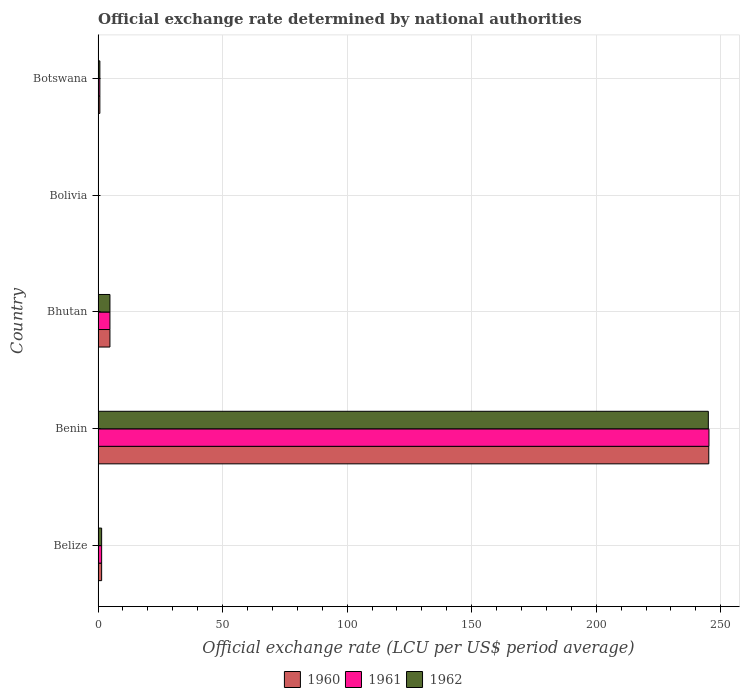Are the number of bars on each tick of the Y-axis equal?
Your answer should be very brief. Yes. What is the label of the 2nd group of bars from the top?
Keep it short and to the point. Bolivia. What is the official exchange rate in 1962 in Benin?
Offer a very short reply. 245.01. Across all countries, what is the maximum official exchange rate in 1962?
Your answer should be compact. 245.01. Across all countries, what is the minimum official exchange rate in 1961?
Offer a terse response. 1.188e-5. In which country was the official exchange rate in 1962 maximum?
Give a very brief answer. Benin. In which country was the official exchange rate in 1960 minimum?
Offer a terse response. Bolivia. What is the total official exchange rate in 1962 in the graph?
Make the answer very short. 251.92. What is the difference between the official exchange rate in 1960 in Bolivia and that in Botswana?
Your answer should be very brief. -0.71. What is the difference between the official exchange rate in 1962 in Bolivia and the official exchange rate in 1961 in Bhutan?
Your answer should be compact. -4.76. What is the average official exchange rate in 1962 per country?
Offer a very short reply. 50.38. In how many countries, is the official exchange rate in 1960 greater than 110 LCU?
Your answer should be very brief. 1. What is the ratio of the official exchange rate in 1961 in Belize to that in Bolivia?
Your response must be concise. 1.20e+05. Is the official exchange rate in 1960 in Benin less than that in Botswana?
Offer a very short reply. No. Is the difference between the official exchange rate in 1961 in Benin and Bhutan greater than the difference between the official exchange rate in 1962 in Benin and Bhutan?
Your answer should be compact. Yes. What is the difference between the highest and the second highest official exchange rate in 1961?
Ensure brevity in your answer.  240.5. What is the difference between the highest and the lowest official exchange rate in 1960?
Keep it short and to the point. 245.2. In how many countries, is the official exchange rate in 1962 greater than the average official exchange rate in 1962 taken over all countries?
Provide a succinct answer. 1. Is the sum of the official exchange rate in 1962 in Benin and Botswana greater than the maximum official exchange rate in 1960 across all countries?
Offer a terse response. Yes. What does the 3rd bar from the top in Belize represents?
Give a very brief answer. 1960. What does the 1st bar from the bottom in Bolivia represents?
Provide a succinct answer. 1960. Is it the case that in every country, the sum of the official exchange rate in 1960 and official exchange rate in 1962 is greater than the official exchange rate in 1961?
Make the answer very short. Yes. How many bars are there?
Provide a short and direct response. 15. How many countries are there in the graph?
Give a very brief answer. 5. What is the difference between two consecutive major ticks on the X-axis?
Provide a succinct answer. 50. Are the values on the major ticks of X-axis written in scientific E-notation?
Give a very brief answer. No. Does the graph contain any zero values?
Your answer should be very brief. No. Does the graph contain grids?
Give a very brief answer. Yes. What is the title of the graph?
Your answer should be compact. Official exchange rate determined by national authorities. Does "1974" appear as one of the legend labels in the graph?
Provide a short and direct response. No. What is the label or title of the X-axis?
Keep it short and to the point. Official exchange rate (LCU per US$ period average). What is the label or title of the Y-axis?
Your answer should be compact. Country. What is the Official exchange rate (LCU per US$ period average) of 1960 in Belize?
Your answer should be compact. 1.43. What is the Official exchange rate (LCU per US$ period average) in 1961 in Belize?
Your response must be concise. 1.43. What is the Official exchange rate (LCU per US$ period average) of 1962 in Belize?
Make the answer very short. 1.43. What is the Official exchange rate (LCU per US$ period average) of 1960 in Benin?
Ensure brevity in your answer.  245.2. What is the Official exchange rate (LCU per US$ period average) in 1961 in Benin?
Keep it short and to the point. 245.26. What is the Official exchange rate (LCU per US$ period average) in 1962 in Benin?
Keep it short and to the point. 245.01. What is the Official exchange rate (LCU per US$ period average) of 1960 in Bhutan?
Offer a very short reply. 4.76. What is the Official exchange rate (LCU per US$ period average) of 1961 in Bhutan?
Give a very brief answer. 4.76. What is the Official exchange rate (LCU per US$ period average) of 1962 in Bhutan?
Your answer should be compact. 4.76. What is the Official exchange rate (LCU per US$ period average) in 1960 in Bolivia?
Your answer should be compact. 1.188e-5. What is the Official exchange rate (LCU per US$ period average) in 1961 in Bolivia?
Offer a very short reply. 1.188e-5. What is the Official exchange rate (LCU per US$ period average) of 1962 in Bolivia?
Offer a terse response. 1.188e-5. What is the Official exchange rate (LCU per US$ period average) in 1960 in Botswana?
Ensure brevity in your answer.  0.71. What is the Official exchange rate (LCU per US$ period average) in 1961 in Botswana?
Your answer should be very brief. 0.71. What is the Official exchange rate (LCU per US$ period average) of 1962 in Botswana?
Provide a short and direct response. 0.71. Across all countries, what is the maximum Official exchange rate (LCU per US$ period average) in 1960?
Offer a very short reply. 245.2. Across all countries, what is the maximum Official exchange rate (LCU per US$ period average) in 1961?
Ensure brevity in your answer.  245.26. Across all countries, what is the maximum Official exchange rate (LCU per US$ period average) of 1962?
Give a very brief answer. 245.01. Across all countries, what is the minimum Official exchange rate (LCU per US$ period average) in 1960?
Your answer should be very brief. 1.188e-5. Across all countries, what is the minimum Official exchange rate (LCU per US$ period average) in 1961?
Give a very brief answer. 1.188e-5. Across all countries, what is the minimum Official exchange rate (LCU per US$ period average) of 1962?
Your answer should be very brief. 1.188e-5. What is the total Official exchange rate (LCU per US$ period average) in 1960 in the graph?
Offer a very short reply. 252.1. What is the total Official exchange rate (LCU per US$ period average) of 1961 in the graph?
Offer a very short reply. 252.17. What is the total Official exchange rate (LCU per US$ period average) in 1962 in the graph?
Give a very brief answer. 251.92. What is the difference between the Official exchange rate (LCU per US$ period average) in 1960 in Belize and that in Benin?
Keep it short and to the point. -243.77. What is the difference between the Official exchange rate (LCU per US$ period average) of 1961 in Belize and that in Benin?
Give a very brief answer. -243.83. What is the difference between the Official exchange rate (LCU per US$ period average) in 1962 in Belize and that in Benin?
Keep it short and to the point. -243.59. What is the difference between the Official exchange rate (LCU per US$ period average) of 1962 in Belize and that in Bhutan?
Make the answer very short. -3.33. What is the difference between the Official exchange rate (LCU per US$ period average) of 1960 in Belize and that in Bolivia?
Offer a very short reply. 1.43. What is the difference between the Official exchange rate (LCU per US$ period average) of 1961 in Belize and that in Bolivia?
Offer a terse response. 1.43. What is the difference between the Official exchange rate (LCU per US$ period average) of 1962 in Belize and that in Bolivia?
Your response must be concise. 1.43. What is the difference between the Official exchange rate (LCU per US$ period average) in 1960 in Belize and that in Botswana?
Your response must be concise. 0.72. What is the difference between the Official exchange rate (LCU per US$ period average) of 1961 in Belize and that in Botswana?
Your answer should be very brief. 0.71. What is the difference between the Official exchange rate (LCU per US$ period average) of 1962 in Belize and that in Botswana?
Offer a very short reply. 0.72. What is the difference between the Official exchange rate (LCU per US$ period average) in 1960 in Benin and that in Bhutan?
Offer a terse response. 240.43. What is the difference between the Official exchange rate (LCU per US$ period average) in 1961 in Benin and that in Bhutan?
Provide a short and direct response. 240.5. What is the difference between the Official exchange rate (LCU per US$ period average) of 1962 in Benin and that in Bhutan?
Make the answer very short. 240.25. What is the difference between the Official exchange rate (LCU per US$ period average) in 1960 in Benin and that in Bolivia?
Offer a very short reply. 245.2. What is the difference between the Official exchange rate (LCU per US$ period average) of 1961 in Benin and that in Bolivia?
Provide a short and direct response. 245.26. What is the difference between the Official exchange rate (LCU per US$ period average) of 1962 in Benin and that in Bolivia?
Give a very brief answer. 245.01. What is the difference between the Official exchange rate (LCU per US$ period average) in 1960 in Benin and that in Botswana?
Ensure brevity in your answer.  244.48. What is the difference between the Official exchange rate (LCU per US$ period average) in 1961 in Benin and that in Botswana?
Offer a very short reply. 244.55. What is the difference between the Official exchange rate (LCU per US$ period average) in 1962 in Benin and that in Botswana?
Your answer should be compact. 244.3. What is the difference between the Official exchange rate (LCU per US$ period average) in 1960 in Bhutan and that in Bolivia?
Provide a short and direct response. 4.76. What is the difference between the Official exchange rate (LCU per US$ period average) of 1961 in Bhutan and that in Bolivia?
Ensure brevity in your answer.  4.76. What is the difference between the Official exchange rate (LCU per US$ period average) in 1962 in Bhutan and that in Bolivia?
Keep it short and to the point. 4.76. What is the difference between the Official exchange rate (LCU per US$ period average) in 1960 in Bhutan and that in Botswana?
Provide a short and direct response. 4.05. What is the difference between the Official exchange rate (LCU per US$ period average) of 1961 in Bhutan and that in Botswana?
Keep it short and to the point. 4.05. What is the difference between the Official exchange rate (LCU per US$ period average) of 1962 in Bhutan and that in Botswana?
Provide a short and direct response. 4.05. What is the difference between the Official exchange rate (LCU per US$ period average) in 1960 in Bolivia and that in Botswana?
Offer a terse response. -0.71. What is the difference between the Official exchange rate (LCU per US$ period average) of 1961 in Bolivia and that in Botswana?
Make the answer very short. -0.71. What is the difference between the Official exchange rate (LCU per US$ period average) in 1962 in Bolivia and that in Botswana?
Offer a very short reply. -0.71. What is the difference between the Official exchange rate (LCU per US$ period average) of 1960 in Belize and the Official exchange rate (LCU per US$ period average) of 1961 in Benin?
Offer a terse response. -243.83. What is the difference between the Official exchange rate (LCU per US$ period average) in 1960 in Belize and the Official exchange rate (LCU per US$ period average) in 1962 in Benin?
Your answer should be compact. -243.59. What is the difference between the Official exchange rate (LCU per US$ period average) in 1961 in Belize and the Official exchange rate (LCU per US$ period average) in 1962 in Benin?
Offer a terse response. -243.59. What is the difference between the Official exchange rate (LCU per US$ period average) of 1961 in Belize and the Official exchange rate (LCU per US$ period average) of 1962 in Bhutan?
Give a very brief answer. -3.33. What is the difference between the Official exchange rate (LCU per US$ period average) of 1960 in Belize and the Official exchange rate (LCU per US$ period average) of 1961 in Bolivia?
Give a very brief answer. 1.43. What is the difference between the Official exchange rate (LCU per US$ period average) of 1960 in Belize and the Official exchange rate (LCU per US$ period average) of 1962 in Bolivia?
Offer a terse response. 1.43. What is the difference between the Official exchange rate (LCU per US$ period average) in 1961 in Belize and the Official exchange rate (LCU per US$ period average) in 1962 in Bolivia?
Provide a succinct answer. 1.43. What is the difference between the Official exchange rate (LCU per US$ period average) of 1960 in Belize and the Official exchange rate (LCU per US$ period average) of 1961 in Botswana?
Your response must be concise. 0.71. What is the difference between the Official exchange rate (LCU per US$ period average) of 1960 in Belize and the Official exchange rate (LCU per US$ period average) of 1962 in Botswana?
Provide a short and direct response. 0.72. What is the difference between the Official exchange rate (LCU per US$ period average) of 1961 in Belize and the Official exchange rate (LCU per US$ period average) of 1962 in Botswana?
Offer a terse response. 0.72. What is the difference between the Official exchange rate (LCU per US$ period average) of 1960 in Benin and the Official exchange rate (LCU per US$ period average) of 1961 in Bhutan?
Keep it short and to the point. 240.43. What is the difference between the Official exchange rate (LCU per US$ period average) in 1960 in Benin and the Official exchange rate (LCU per US$ period average) in 1962 in Bhutan?
Provide a succinct answer. 240.43. What is the difference between the Official exchange rate (LCU per US$ period average) in 1961 in Benin and the Official exchange rate (LCU per US$ period average) in 1962 in Bhutan?
Your answer should be very brief. 240.5. What is the difference between the Official exchange rate (LCU per US$ period average) in 1960 in Benin and the Official exchange rate (LCU per US$ period average) in 1961 in Bolivia?
Provide a succinct answer. 245.2. What is the difference between the Official exchange rate (LCU per US$ period average) in 1960 in Benin and the Official exchange rate (LCU per US$ period average) in 1962 in Bolivia?
Provide a succinct answer. 245.2. What is the difference between the Official exchange rate (LCU per US$ period average) in 1961 in Benin and the Official exchange rate (LCU per US$ period average) in 1962 in Bolivia?
Keep it short and to the point. 245.26. What is the difference between the Official exchange rate (LCU per US$ period average) of 1960 in Benin and the Official exchange rate (LCU per US$ period average) of 1961 in Botswana?
Keep it short and to the point. 244.48. What is the difference between the Official exchange rate (LCU per US$ period average) in 1960 in Benin and the Official exchange rate (LCU per US$ period average) in 1962 in Botswana?
Provide a short and direct response. 244.48. What is the difference between the Official exchange rate (LCU per US$ period average) in 1961 in Benin and the Official exchange rate (LCU per US$ period average) in 1962 in Botswana?
Your answer should be compact. 244.55. What is the difference between the Official exchange rate (LCU per US$ period average) in 1960 in Bhutan and the Official exchange rate (LCU per US$ period average) in 1961 in Bolivia?
Provide a succinct answer. 4.76. What is the difference between the Official exchange rate (LCU per US$ period average) of 1960 in Bhutan and the Official exchange rate (LCU per US$ period average) of 1962 in Bolivia?
Ensure brevity in your answer.  4.76. What is the difference between the Official exchange rate (LCU per US$ period average) in 1961 in Bhutan and the Official exchange rate (LCU per US$ period average) in 1962 in Bolivia?
Give a very brief answer. 4.76. What is the difference between the Official exchange rate (LCU per US$ period average) in 1960 in Bhutan and the Official exchange rate (LCU per US$ period average) in 1961 in Botswana?
Make the answer very short. 4.05. What is the difference between the Official exchange rate (LCU per US$ period average) of 1960 in Bhutan and the Official exchange rate (LCU per US$ period average) of 1962 in Botswana?
Provide a succinct answer. 4.05. What is the difference between the Official exchange rate (LCU per US$ period average) of 1961 in Bhutan and the Official exchange rate (LCU per US$ period average) of 1962 in Botswana?
Your answer should be compact. 4.05. What is the difference between the Official exchange rate (LCU per US$ period average) of 1960 in Bolivia and the Official exchange rate (LCU per US$ period average) of 1961 in Botswana?
Make the answer very short. -0.71. What is the difference between the Official exchange rate (LCU per US$ period average) in 1960 in Bolivia and the Official exchange rate (LCU per US$ period average) in 1962 in Botswana?
Make the answer very short. -0.71. What is the difference between the Official exchange rate (LCU per US$ period average) in 1961 in Bolivia and the Official exchange rate (LCU per US$ period average) in 1962 in Botswana?
Ensure brevity in your answer.  -0.71. What is the average Official exchange rate (LCU per US$ period average) in 1960 per country?
Your answer should be compact. 50.42. What is the average Official exchange rate (LCU per US$ period average) in 1961 per country?
Keep it short and to the point. 50.43. What is the average Official exchange rate (LCU per US$ period average) in 1962 per country?
Keep it short and to the point. 50.38. What is the difference between the Official exchange rate (LCU per US$ period average) of 1960 and Official exchange rate (LCU per US$ period average) of 1961 in Belize?
Give a very brief answer. 0. What is the difference between the Official exchange rate (LCU per US$ period average) of 1961 and Official exchange rate (LCU per US$ period average) of 1962 in Belize?
Ensure brevity in your answer.  0. What is the difference between the Official exchange rate (LCU per US$ period average) in 1960 and Official exchange rate (LCU per US$ period average) in 1961 in Benin?
Ensure brevity in your answer.  -0.07. What is the difference between the Official exchange rate (LCU per US$ period average) of 1960 and Official exchange rate (LCU per US$ period average) of 1962 in Benin?
Your response must be concise. 0.18. What is the difference between the Official exchange rate (LCU per US$ period average) in 1961 and Official exchange rate (LCU per US$ period average) in 1962 in Benin?
Keep it short and to the point. 0.25. What is the difference between the Official exchange rate (LCU per US$ period average) in 1960 and Official exchange rate (LCU per US$ period average) in 1962 in Bhutan?
Offer a terse response. 0. What is the difference between the Official exchange rate (LCU per US$ period average) in 1961 and Official exchange rate (LCU per US$ period average) in 1962 in Bhutan?
Give a very brief answer. 0. What is the difference between the Official exchange rate (LCU per US$ period average) in 1960 and Official exchange rate (LCU per US$ period average) in 1961 in Bolivia?
Keep it short and to the point. 0. What is the difference between the Official exchange rate (LCU per US$ period average) of 1960 and Official exchange rate (LCU per US$ period average) of 1962 in Bolivia?
Your response must be concise. 0. What is the difference between the Official exchange rate (LCU per US$ period average) of 1960 and Official exchange rate (LCU per US$ period average) of 1961 in Botswana?
Your response must be concise. -0. What is the difference between the Official exchange rate (LCU per US$ period average) in 1960 and Official exchange rate (LCU per US$ period average) in 1962 in Botswana?
Your answer should be very brief. 0. What is the difference between the Official exchange rate (LCU per US$ period average) in 1961 and Official exchange rate (LCU per US$ period average) in 1962 in Botswana?
Provide a short and direct response. 0. What is the ratio of the Official exchange rate (LCU per US$ period average) of 1960 in Belize to that in Benin?
Your answer should be compact. 0.01. What is the ratio of the Official exchange rate (LCU per US$ period average) of 1961 in Belize to that in Benin?
Make the answer very short. 0.01. What is the ratio of the Official exchange rate (LCU per US$ period average) of 1962 in Belize to that in Benin?
Provide a short and direct response. 0.01. What is the ratio of the Official exchange rate (LCU per US$ period average) in 1962 in Belize to that in Bhutan?
Make the answer very short. 0.3. What is the ratio of the Official exchange rate (LCU per US$ period average) of 1960 in Belize to that in Bolivia?
Your answer should be compact. 1.20e+05. What is the ratio of the Official exchange rate (LCU per US$ period average) in 1961 in Belize to that in Bolivia?
Offer a very short reply. 1.20e+05. What is the ratio of the Official exchange rate (LCU per US$ period average) in 1962 in Belize to that in Bolivia?
Ensure brevity in your answer.  1.20e+05. What is the ratio of the Official exchange rate (LCU per US$ period average) in 1960 in Belize to that in Botswana?
Give a very brief answer. 2. What is the ratio of the Official exchange rate (LCU per US$ period average) in 1961 in Belize to that in Botswana?
Your answer should be very brief. 2. What is the ratio of the Official exchange rate (LCU per US$ period average) in 1962 in Belize to that in Botswana?
Provide a short and direct response. 2. What is the ratio of the Official exchange rate (LCU per US$ period average) in 1960 in Benin to that in Bhutan?
Give a very brief answer. 51.49. What is the ratio of the Official exchange rate (LCU per US$ period average) of 1961 in Benin to that in Bhutan?
Ensure brevity in your answer.  51.5. What is the ratio of the Official exchange rate (LCU per US$ period average) of 1962 in Benin to that in Bhutan?
Keep it short and to the point. 51.45. What is the ratio of the Official exchange rate (LCU per US$ period average) in 1960 in Benin to that in Bolivia?
Offer a terse response. 2.06e+07. What is the ratio of the Official exchange rate (LCU per US$ period average) in 1961 in Benin to that in Bolivia?
Your answer should be compact. 2.06e+07. What is the ratio of the Official exchange rate (LCU per US$ period average) of 1962 in Benin to that in Bolivia?
Offer a very short reply. 2.06e+07. What is the ratio of the Official exchange rate (LCU per US$ period average) of 1960 in Benin to that in Botswana?
Your response must be concise. 343.74. What is the ratio of the Official exchange rate (LCU per US$ period average) of 1961 in Benin to that in Botswana?
Provide a short and direct response. 343.17. What is the ratio of the Official exchange rate (LCU per US$ period average) in 1962 in Benin to that in Botswana?
Your answer should be very brief. 343.51. What is the ratio of the Official exchange rate (LCU per US$ period average) of 1960 in Bhutan to that in Bolivia?
Make the answer very short. 4.01e+05. What is the ratio of the Official exchange rate (LCU per US$ period average) of 1961 in Bhutan to that in Bolivia?
Keep it short and to the point. 4.01e+05. What is the ratio of the Official exchange rate (LCU per US$ period average) in 1962 in Bhutan to that in Bolivia?
Offer a very short reply. 4.01e+05. What is the ratio of the Official exchange rate (LCU per US$ period average) of 1960 in Bhutan to that in Botswana?
Your response must be concise. 6.68. What is the ratio of the Official exchange rate (LCU per US$ period average) of 1961 in Bhutan to that in Botswana?
Keep it short and to the point. 6.66. What is the ratio of the Official exchange rate (LCU per US$ period average) in 1962 in Bhutan to that in Botswana?
Your answer should be compact. 6.68. What is the ratio of the Official exchange rate (LCU per US$ period average) of 1960 in Bolivia to that in Botswana?
Provide a short and direct response. 0. What is the ratio of the Official exchange rate (LCU per US$ period average) in 1962 in Bolivia to that in Botswana?
Give a very brief answer. 0. What is the difference between the highest and the second highest Official exchange rate (LCU per US$ period average) in 1960?
Keep it short and to the point. 240.43. What is the difference between the highest and the second highest Official exchange rate (LCU per US$ period average) in 1961?
Make the answer very short. 240.5. What is the difference between the highest and the second highest Official exchange rate (LCU per US$ period average) in 1962?
Keep it short and to the point. 240.25. What is the difference between the highest and the lowest Official exchange rate (LCU per US$ period average) of 1960?
Provide a succinct answer. 245.2. What is the difference between the highest and the lowest Official exchange rate (LCU per US$ period average) of 1961?
Give a very brief answer. 245.26. What is the difference between the highest and the lowest Official exchange rate (LCU per US$ period average) of 1962?
Keep it short and to the point. 245.01. 